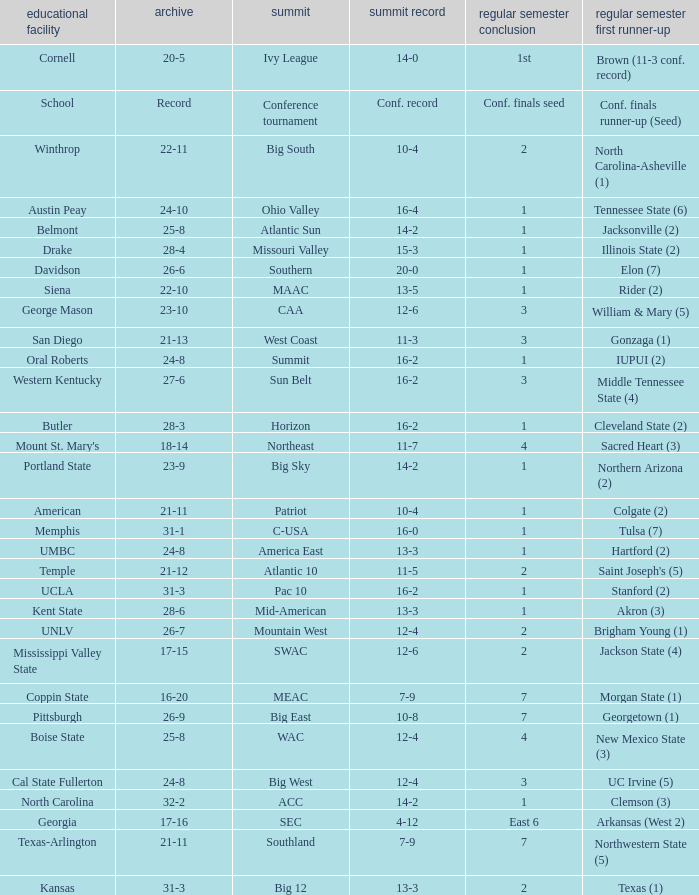Which qualifying schools were in the Patriot conference? American. 